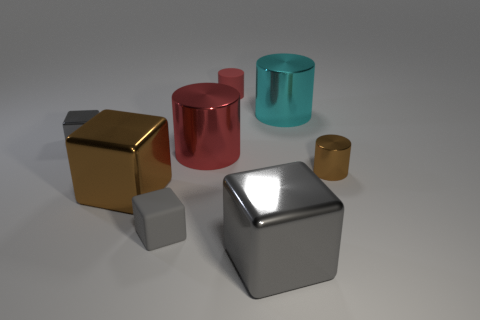Are there any other things that are the same shape as the small brown metallic thing?
Keep it short and to the point. Yes. Does the big gray thing have the same material as the red thing behind the red metal cylinder?
Give a very brief answer. No. The big cube to the left of the tiny thing behind the gray shiny object behind the large gray object is what color?
Your answer should be compact. Brown. Is there anything else that is the same size as the red metal thing?
Keep it short and to the point. Yes. Do the small rubber block and the small shiny thing right of the red matte cylinder have the same color?
Your response must be concise. No. The small metallic cylinder has what color?
Make the answer very short. Brown. There is a gray metallic object left of the metallic block that is in front of the small gray rubber thing that is in front of the large cyan shiny object; what is its shape?
Your answer should be compact. Cube. How many other things are there of the same color as the rubber cube?
Keep it short and to the point. 2. Is the number of tiny things that are in front of the small gray metal object greater than the number of red rubber cylinders that are behind the red rubber cylinder?
Keep it short and to the point. Yes. There is a large cyan metal cylinder; are there any cyan shiny cylinders on the right side of it?
Give a very brief answer. No. 